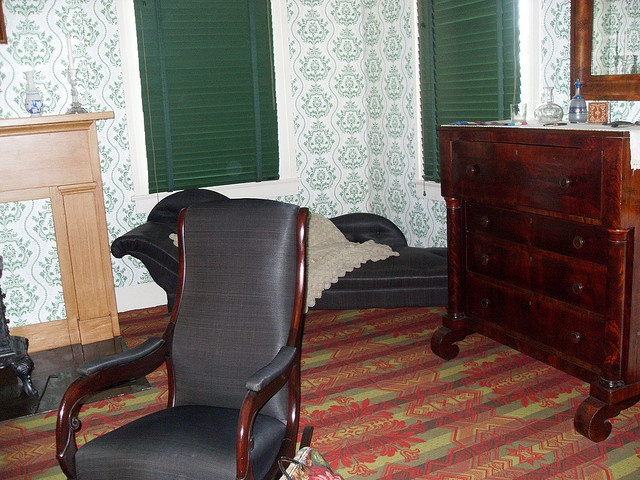Describe the objects in this image and their specific colors. I can see chair in maroon, gray, and black tones, couch in maroon, black, and gray tones, handbag in maroon, brown, gray, and lightpink tones, vase in maroon, lightgray, and darkgray tones, and vase in maroon, lightgray, and darkgray tones in this image. 